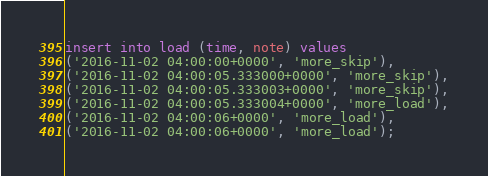Convert code to text. <code><loc_0><loc_0><loc_500><loc_500><_SQL_>
insert into load (time, note) values
('2016-11-02 04:00:00+0000', 'more_skip'),
('2016-11-02 04:00:05.333000+0000', 'more_skip'),
('2016-11-02 04:00:05.333003+0000', 'more_skip'),
('2016-11-02 04:00:05.333004+0000', 'more_load'),
('2016-11-02 04:00:06+0000', 'more_load'),
('2016-11-02 04:00:06+0000', 'more_load');

</code> 